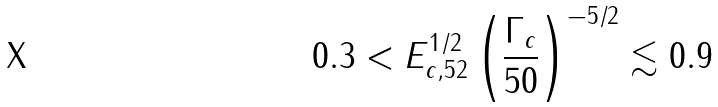<formula> <loc_0><loc_0><loc_500><loc_500>0 . 3 < E _ { c , 5 2 } ^ { 1 / 2 } \left ( \frac { \Gamma _ { c } } { 5 0 } \right ) ^ { - 5 / 2 } \lesssim 0 . 9</formula> 